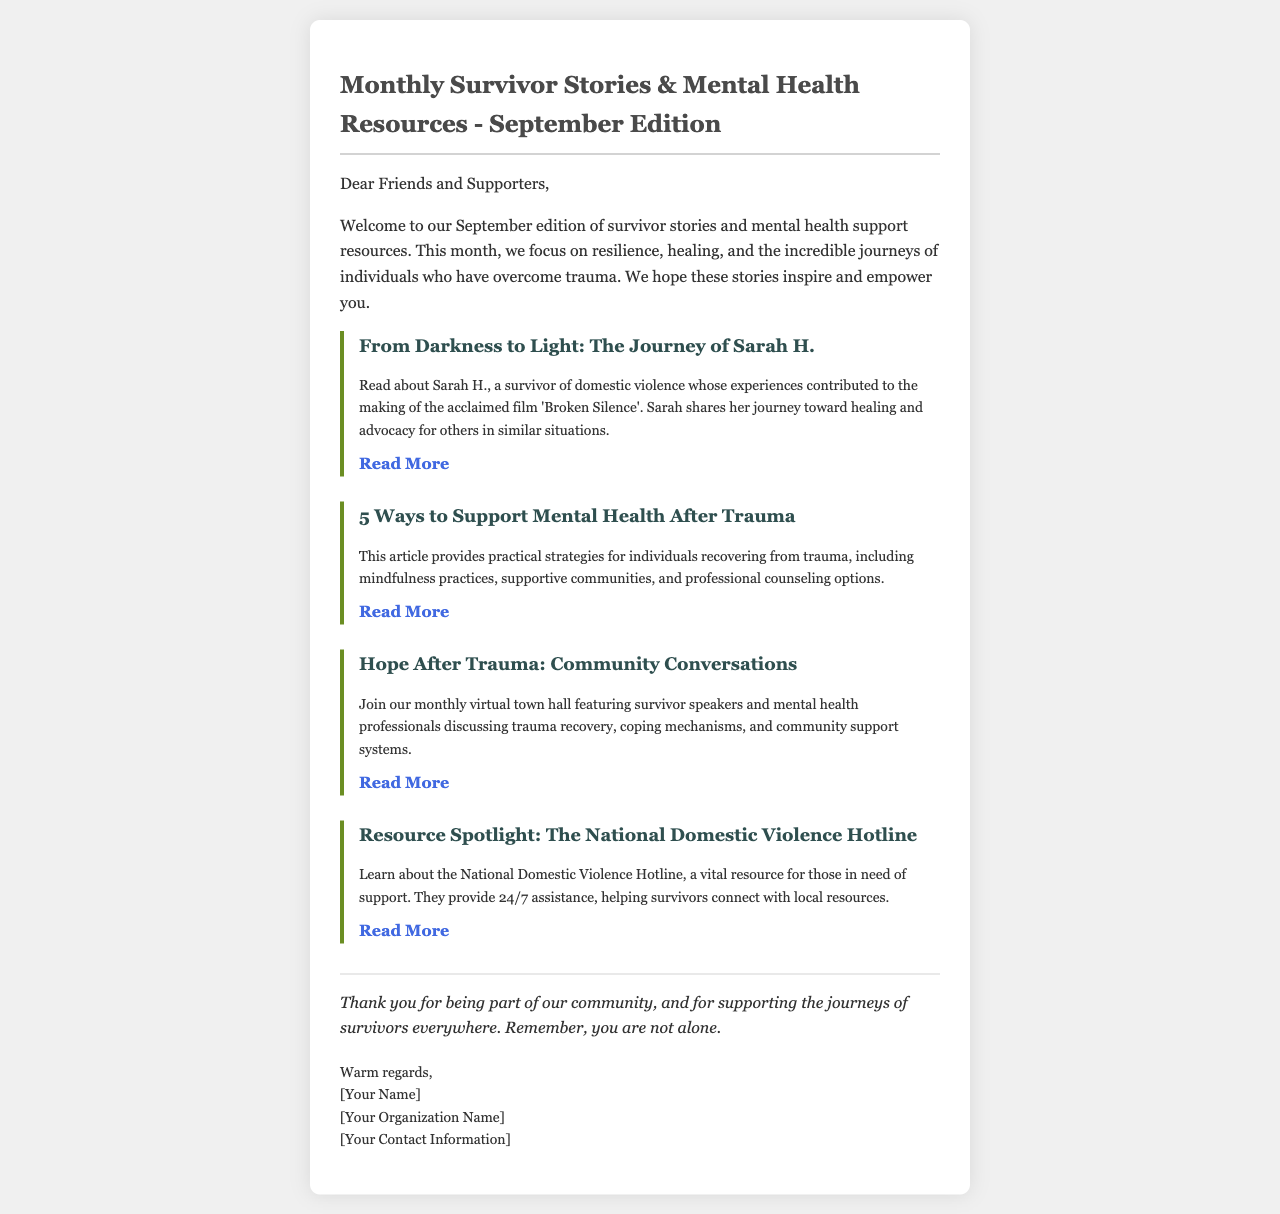What is the title of the newsletter? The title of the newsletter is mentioned at the top of the document.
Answer: Monthly Survivor Stories & Mental Health Resources - September Edition Who is featured in the first article? The first article introduces a survivor, providing their name and context about their story.
Answer: Sarah H What is one of the topics discussed in the second article? The second article provides strategies focused on a specific aspect relating to trauma recovery.
Answer: Mental health support How many ways to support mental health after trauma are outlined in the article? The document indicates a specific number of ways mentioned in the article.
Answer: 5 ways What is the focus of the community conversations mentioned in the newsletter? The community conversations are centered around a specific theme related to exploring recovery.
Answer: Trauma recovery What type of resource is highlighted in the last article? The last article spotlights a specific type of service important for survivors.
Answer: The National Domestic Violence Hotline What phrase is used to express appreciation to the community? The document includes a phrase detailing gratitude towards the readers and supporters.
Answer: Thank you for being part of our community What is the primary goal of the newsletter? The document opens with a summary of the newsletter's mission and focus.
Answer: To inspire and empower 